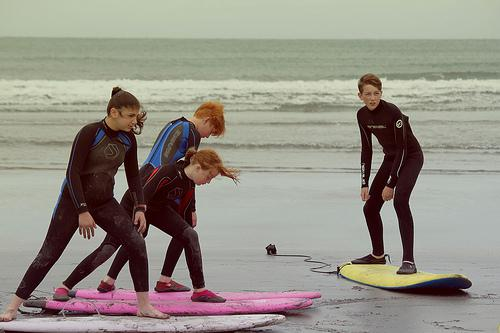Question: where is this picture taken?
Choices:
A. Near the water.
B. On the sand.
C. The beach.
D. Near people.
Answer with the letter. Answer: C Question: who is in the picture?
Choices:
A. People.
B. Two girls and two boys.
C. Kids.
D. Children.
Answer with the letter. Answer: B Question: what are these children going to do?
Choices:
A. Play.
B. Swim.
C. Have fun.
D. Surf.
Answer with the letter. Answer: D Question: how is the weather?
Choices:
A. Cloudy.
B. Hazy.
C. Dark.
D. Overcast.
Answer with the letter. Answer: D Question: what is in the background?
Choices:
A. Water.
B. The ocean.
C. Waves.
D. Sand.
Answer with the letter. Answer: B 